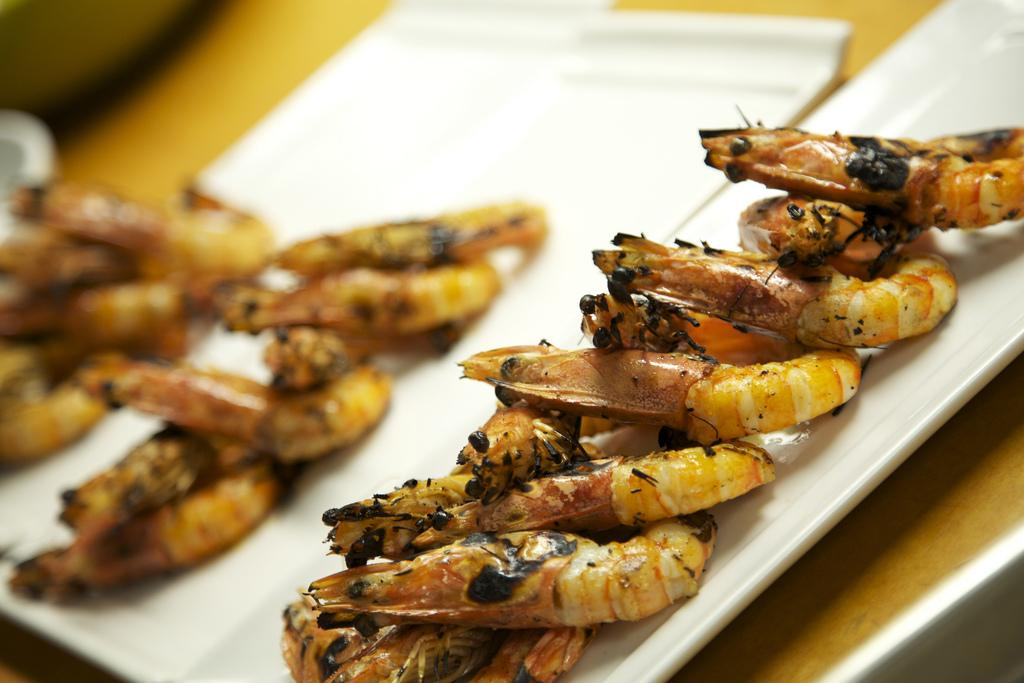What type of seafood is present in the image? There are prawns in the image. How are the prawns arranged or displayed? The prawns are in trays. Where are the trays with prawns located? The trays are placed on a table. What type of pizzas can be seen on the airplane in the image? There is no airplane or pizzas present in the image; it features trays of prawns on a table. 